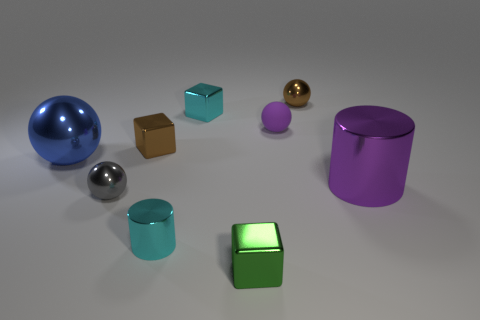Subtract all tiny brown metallic cubes. How many cubes are left? 2 Add 1 large blue metallic spheres. How many objects exist? 10 Subtract all balls. How many objects are left? 5 Subtract 3 blocks. How many blocks are left? 0 Subtract all big purple spheres. Subtract all blue metal objects. How many objects are left? 8 Add 1 large blue metallic things. How many large blue metallic things are left? 2 Add 3 large red metal cylinders. How many large red metal cylinders exist? 3 Subtract all cyan blocks. How many blocks are left? 2 Subtract 0 yellow cylinders. How many objects are left? 9 Subtract all gray cylinders. Subtract all cyan balls. How many cylinders are left? 2 